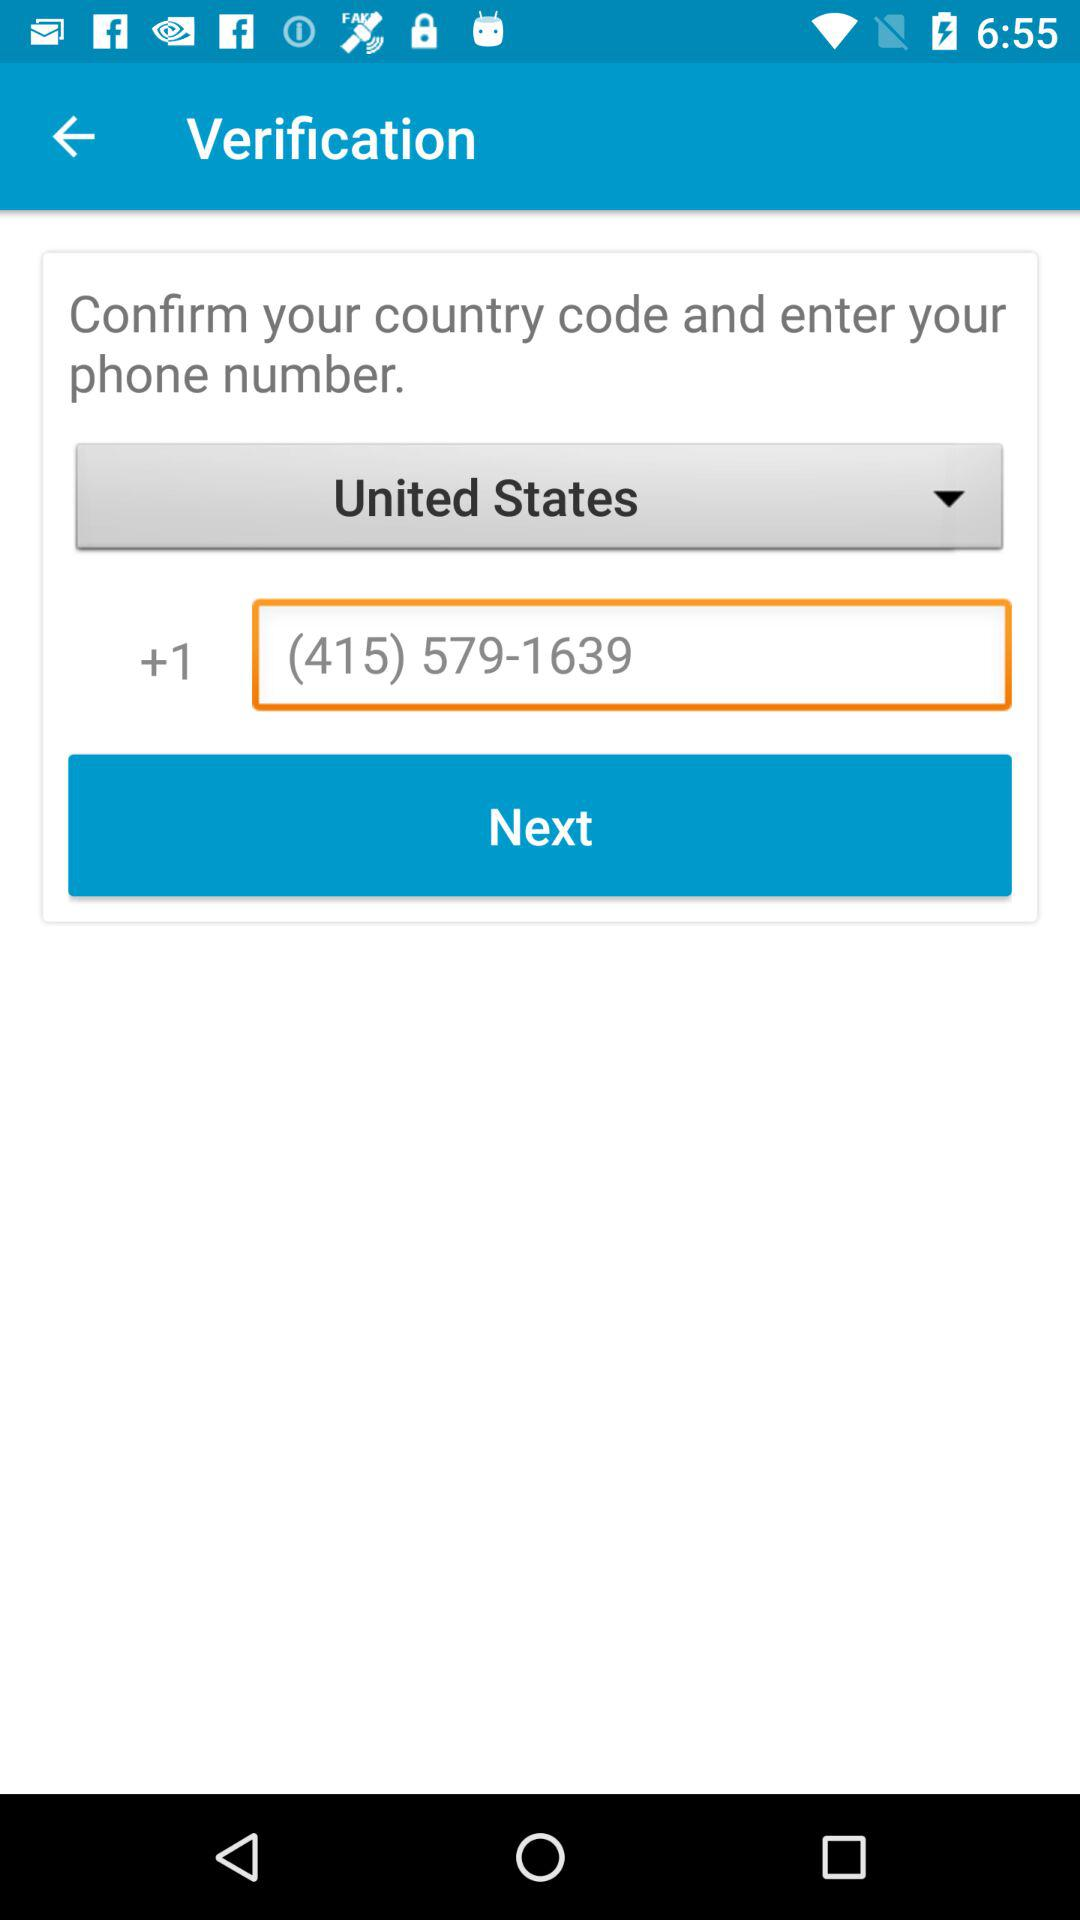What is the selected country? The selected country is the United States. 